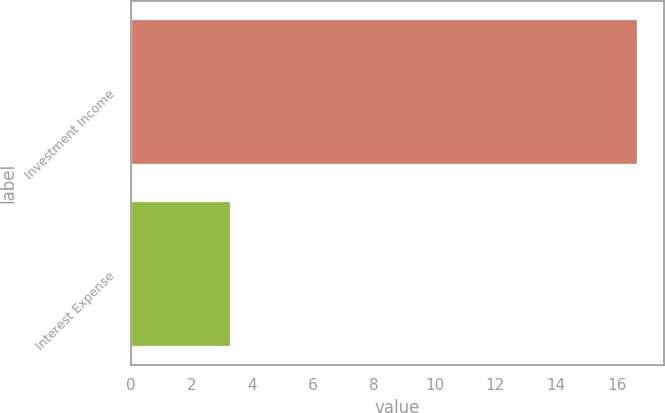<chart> <loc_0><loc_0><loc_500><loc_500><bar_chart><fcel>Investment Income<fcel>Interest Expense<nl><fcel>16.7<fcel>3.3<nl></chart> 